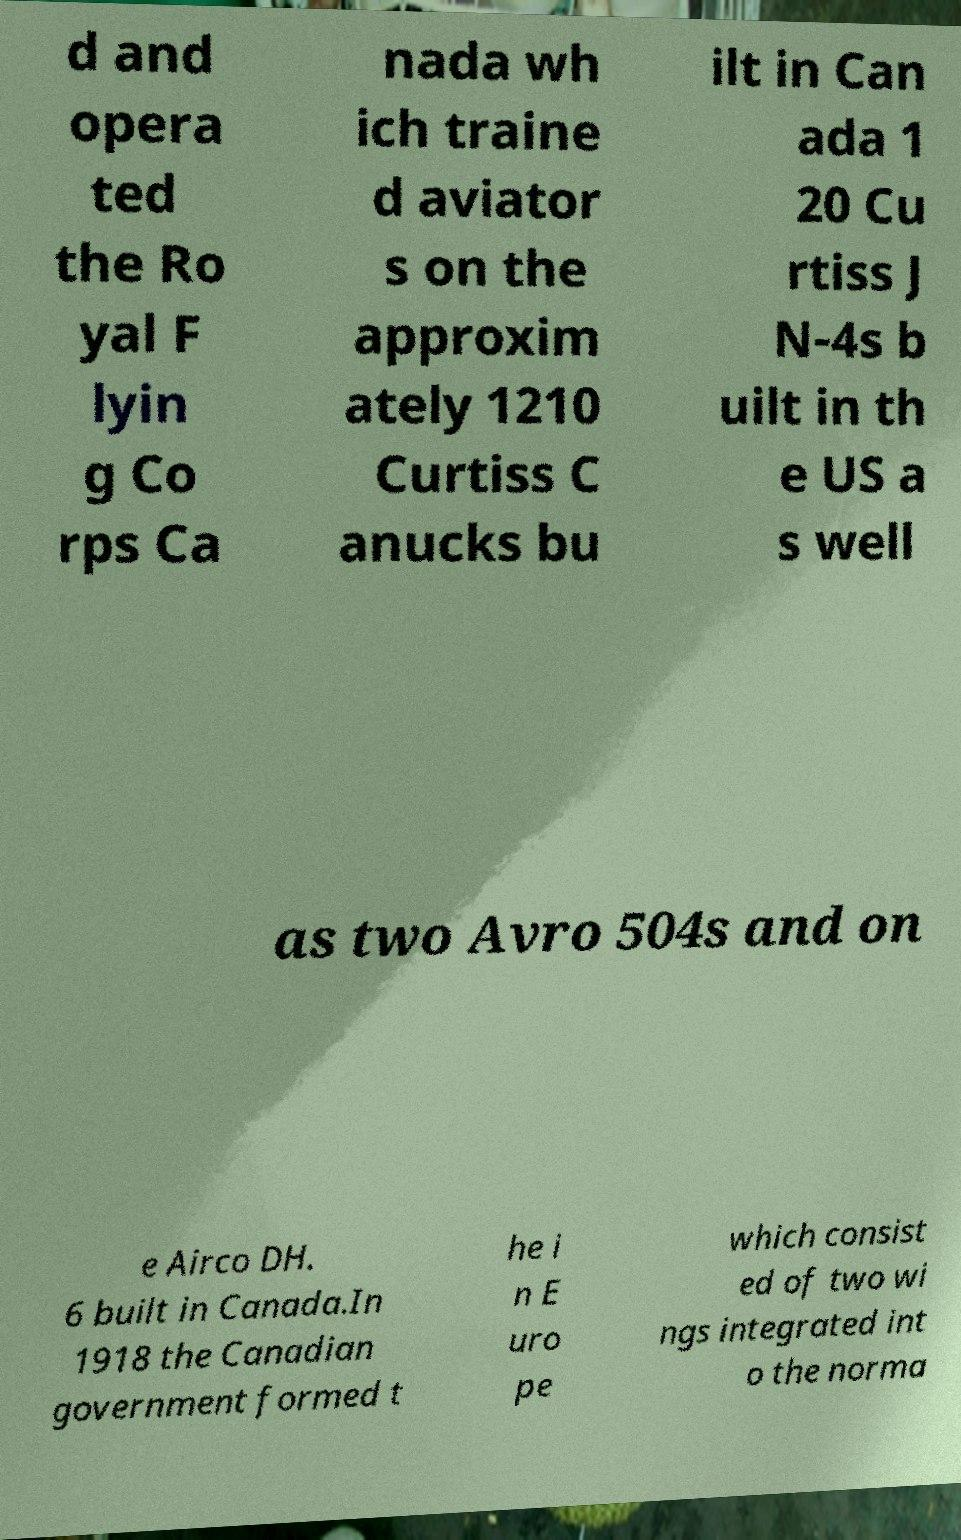Can you read and provide the text displayed in the image?This photo seems to have some interesting text. Can you extract and type it out for me? d and opera ted the Ro yal F lyin g Co rps Ca nada wh ich traine d aviator s on the approxim ately 1210 Curtiss C anucks bu ilt in Can ada 1 20 Cu rtiss J N-4s b uilt in th e US a s well as two Avro 504s and on e Airco DH. 6 built in Canada.In 1918 the Canadian government formed t he i n E uro pe which consist ed of two wi ngs integrated int o the norma 